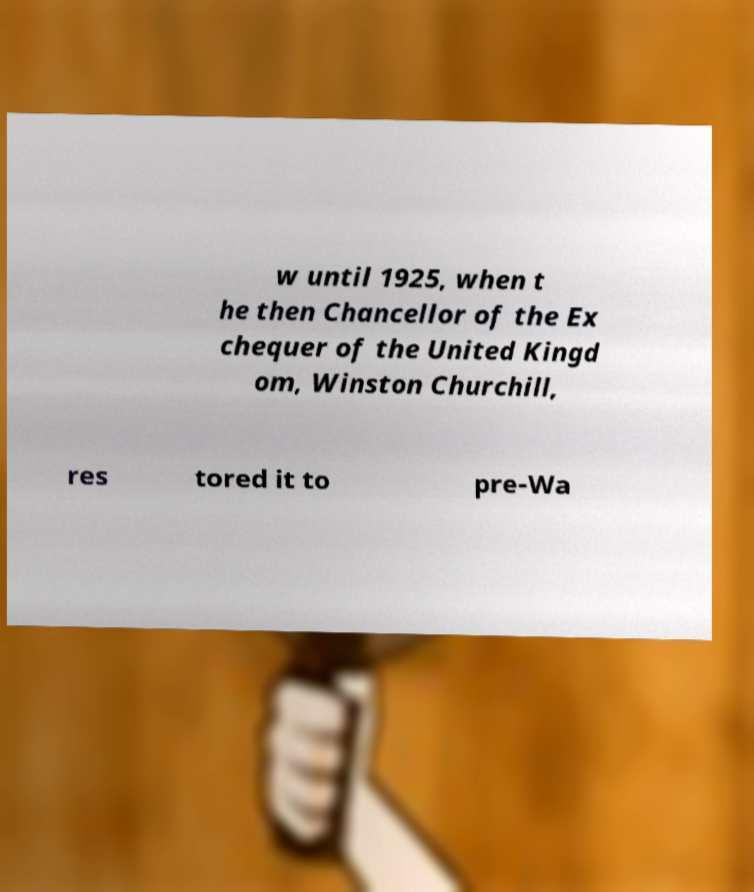There's text embedded in this image that I need extracted. Can you transcribe it verbatim? w until 1925, when t he then Chancellor of the Ex chequer of the United Kingd om, Winston Churchill, res tored it to pre-Wa 